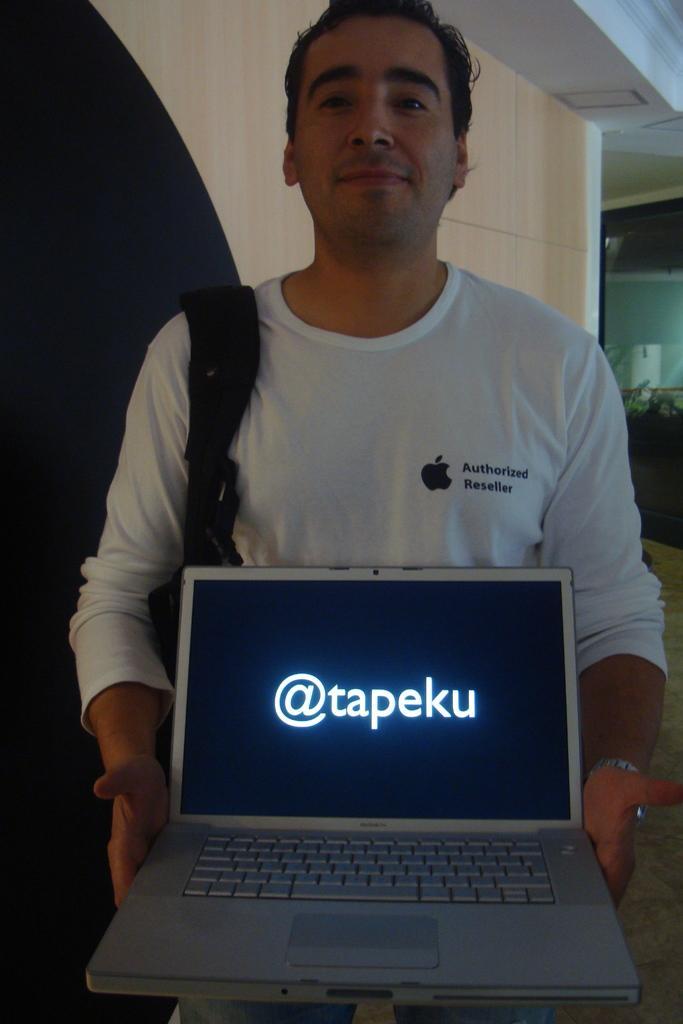How would you summarize this image in a sentence or two? In the front of the image I can see a person wore bag and holding a laptop. Something is written on the laptop screen. In the background of the image there is a wooden wall, ceiling, glass door and objects.   